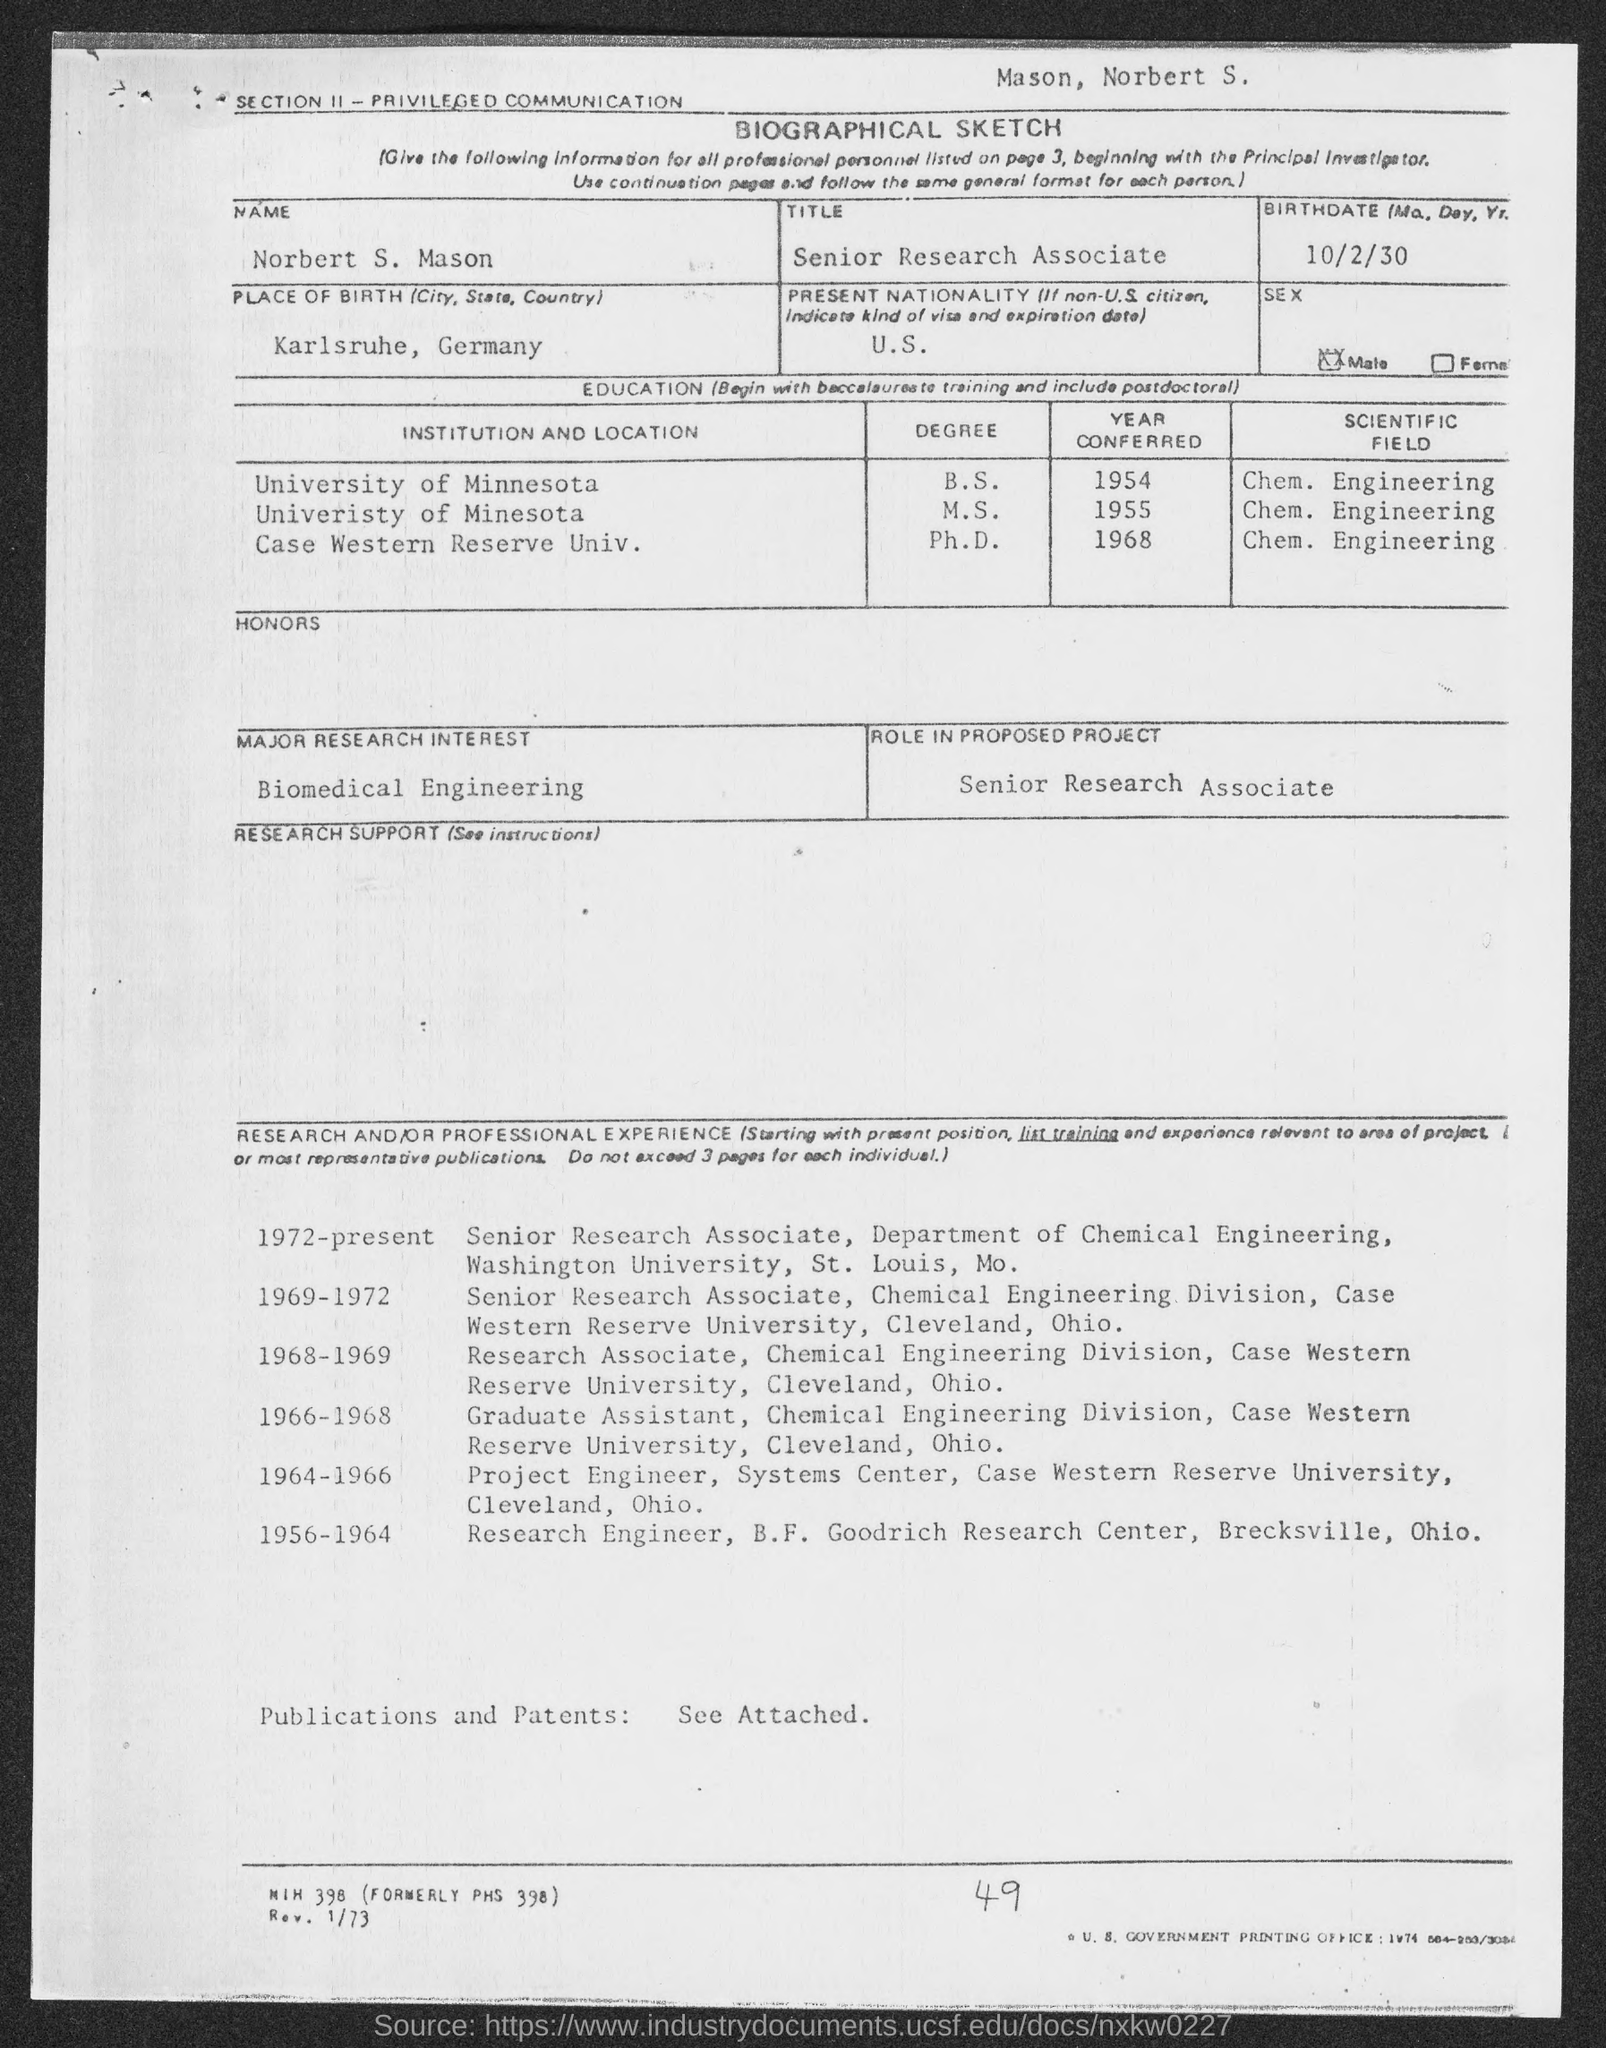Indicate a few pertinent items in this graphic. Norbert S. Mason completed his B.S. degree from the University of Minnesota. Norbert S. Mason completed his M.S. in 1955. Norbert S. Mason was born in Karlsruhe, Germany. On October 2, 1930, Norbert S. Mason was born. Norbert S. Mason completed his Ph.D. in 1968. 